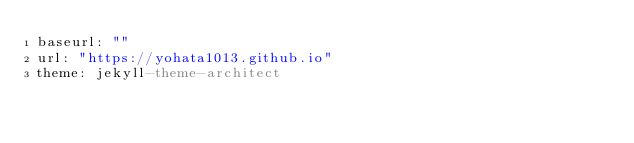<code> <loc_0><loc_0><loc_500><loc_500><_YAML_>baseurl: ""
url: "https://yohata1013.github.io"
theme: jekyll-theme-architect
</code> 